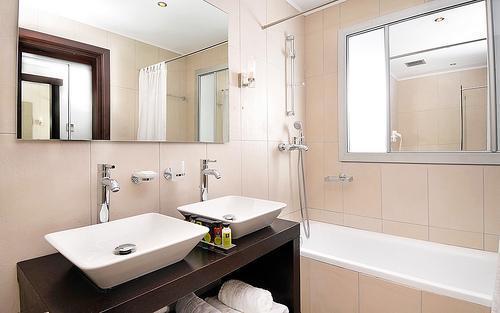How many sinks are there?
Give a very brief answer. 2. 